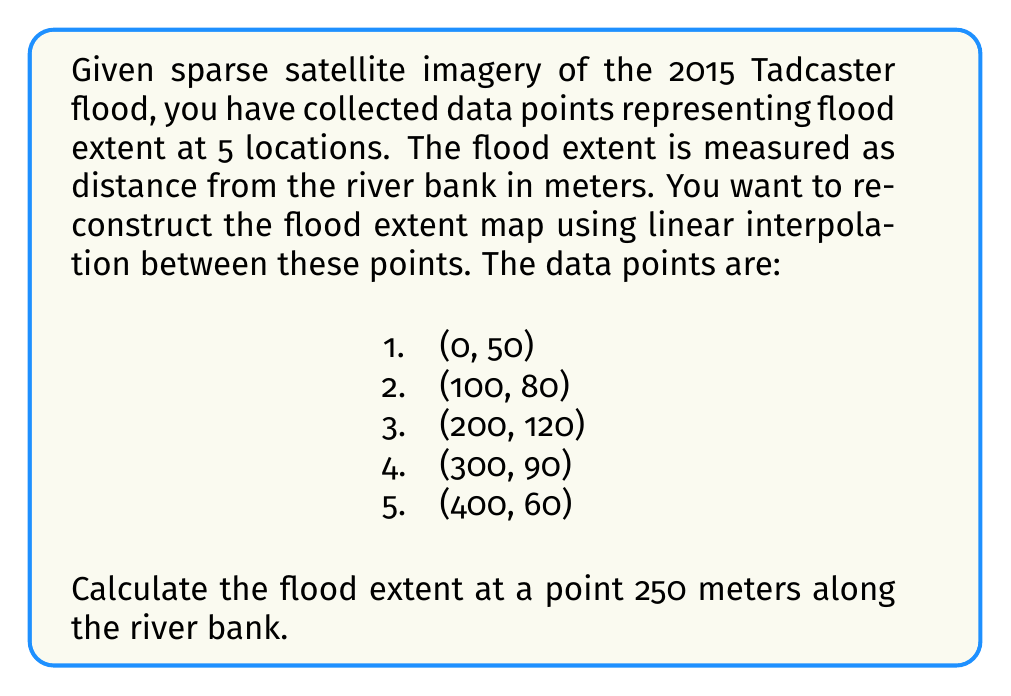Can you answer this question? To solve this problem, we'll use linear interpolation between the known data points. The point we're interested in (250 meters) falls between the third and fourth data points.

Step 1: Identify the two surrounding data points
Point A: (200, 120)
Point B: (300, 90)

Step 2: Calculate the slope of the line between these points
$$ m = \frac{y_2 - y_1}{x_2 - x_1} = \frac{90 - 120}{300 - 200} = -\frac{30}{100} = -0.3 $$

Step 3: Use the point-slope form of a line to create an equation
$$ y - y_1 = m(x - x_1) $$
$$ y - 120 = -0.3(x - 200) $$

Step 4: Plug in x = 250 to find y
$$ y - 120 = -0.3(250 - 200) $$
$$ y - 120 = -0.3(50) = -15 $$
$$ y = 120 - 15 = 105 $$

Therefore, at 250 meters along the river bank, the flood extent is estimated to be 105 meters from the bank.
Answer: 105 meters 